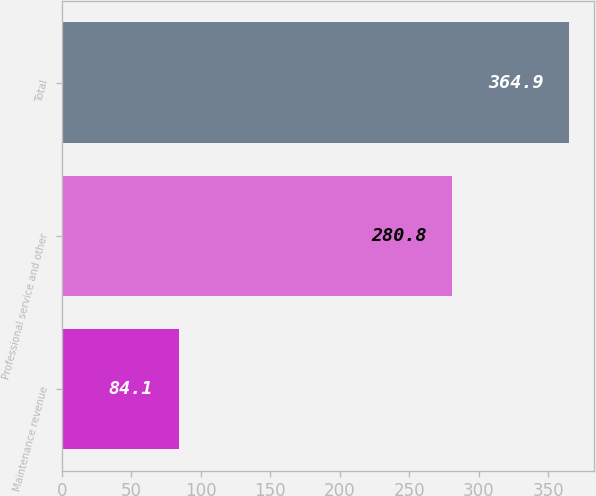Convert chart to OTSL. <chart><loc_0><loc_0><loc_500><loc_500><bar_chart><fcel>Maintenance revenue<fcel>Professional service and other<fcel>Total<nl><fcel>84.1<fcel>280.8<fcel>364.9<nl></chart> 